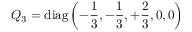<formula> <loc_0><loc_0><loc_500><loc_500>Q _ { 3 } = d i a g \left ( - { \frac { 1 } { 3 } } , - { \frac { 1 } { 3 } } , + { \frac { 2 } { 3 } } , 0 , 0 \right )</formula> 